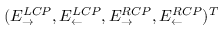Convert formula to latex. <formula><loc_0><loc_0><loc_500><loc_500>( E _ { \rightarrow } ^ { L C P } , E _ { \leftarrow } ^ { L C P } , E _ { \rightarrow } ^ { R C P } , E _ { \leftarrow } ^ { R C P } ) ^ { T }</formula> 